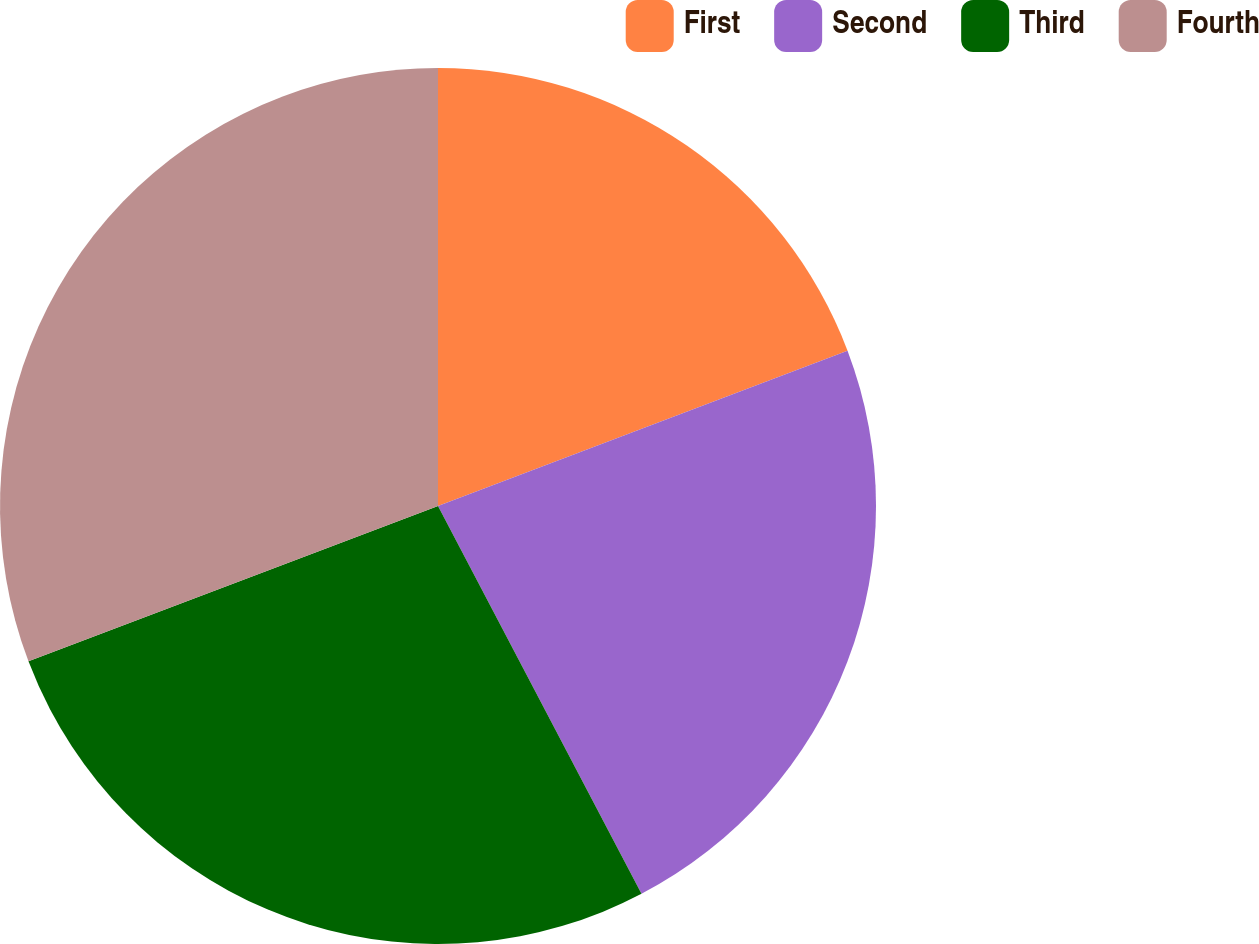Convert chart to OTSL. <chart><loc_0><loc_0><loc_500><loc_500><pie_chart><fcel>First<fcel>Second<fcel>Third<fcel>Fourth<nl><fcel>19.23%<fcel>23.08%<fcel>26.92%<fcel>30.77%<nl></chart> 